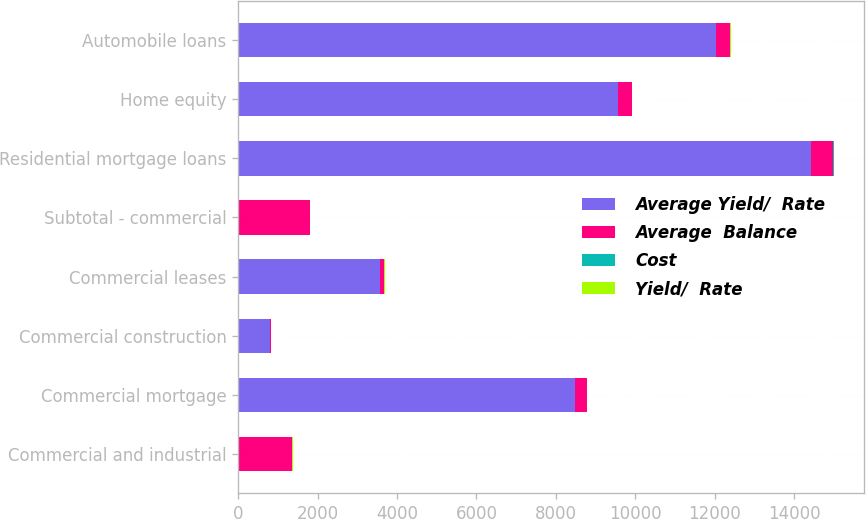<chart> <loc_0><loc_0><loc_500><loc_500><stacked_bar_chart><ecel><fcel>Commercial and industrial<fcel>Commercial mortgage<fcel>Commercial construction<fcel>Commercial leases<fcel>Subtotal - commercial<fcel>Residential mortgage loans<fcel>Home equity<fcel>Automobile loans<nl><fcel>Average Yield/  Rate<fcel>4.08<fcel>8481<fcel>793<fcel>3565<fcel>4.08<fcel>14428<fcel>9554<fcel>12021<nl><fcel>Average  Balance<fcel>1361<fcel>306<fcel>27<fcel>116<fcel>1810<fcel>564<fcel>355<fcel>373<nl><fcel>Cost<fcel>3.6<fcel>3.6<fcel>3.45<fcel>3.26<fcel>3.58<fcel>3.91<fcel>3.71<fcel>3.1<nl><fcel>Yield/  Rate<fcel>4.1<fcel>3.81<fcel>2.99<fcel>3.62<fcel>3.98<fcel>4.06<fcel>3.79<fcel>3.7<nl></chart> 